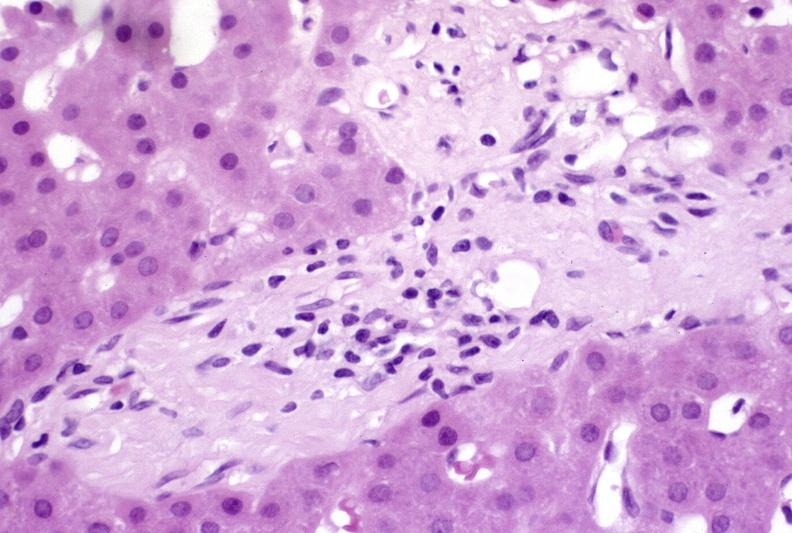s muscle atrophy present?
Answer the question using a single word or phrase. No 